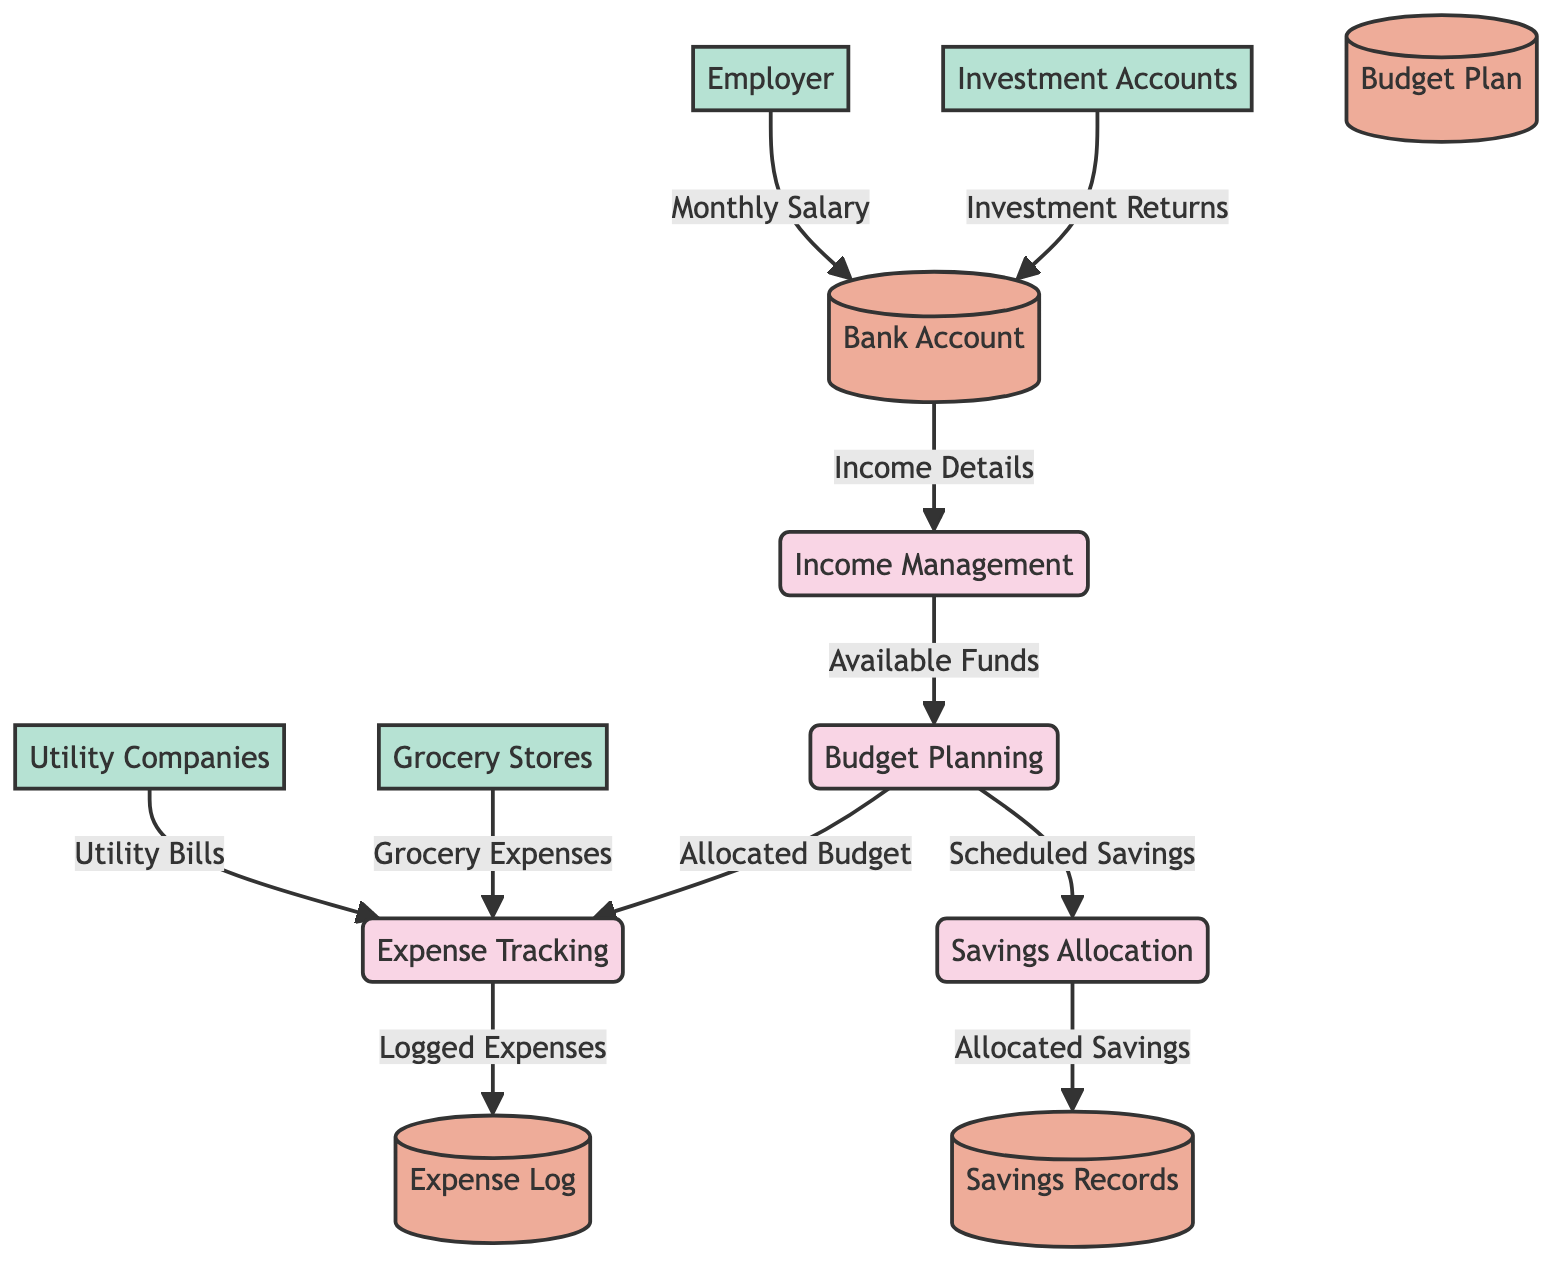What is the first process in the diagram? The first process listed in the diagram is "Income Management," which is labeled as P1.
Answer: Income Management How many data stores are included in the diagram? There are a total of four data stores, which are Bank Account, Expense Log, Budget Plan, and Savings Records.
Answer: Four What data flows from the Employer to the Bank Account? The data flow from the Employer to the Bank Account is the "Monthly Salary." This is indicated by the connection F1 between these two entities.
Answer: Monthly Salary Which process receives "Utility Bills" as input? The process that receives "Utility Bills" is "Expense Tracking," which is connected to the Utility Companies through data flow F7.
Answer: Expense Tracking What is the final output of the Savings Allocation process? The final output of the Savings Allocation process is "Allocated Savings," which is sent to the Savings Records data store indicated by flow F10.
Answer: Allocated Savings What is the relationship between Budget Planning and Savings Allocation? The relationship is that Budget Planning sends "Scheduled Savings" to Savings Allocation, which indicates that the budgeted amounts are being allocated towards savings. This is represented by the flow F9 in the diagram.
Answer: Scheduled Savings Which external entity provides additional income sources? The external entity that provides additional income sources is "Investment Accounts." This is indicated in the diagram with the data flow from Investment Accounts to the Bank Account as "Investment Returns."
Answer: Investment Accounts What type of information is stored in the Expense Log? The Expense Log stores "Detailed records of all household expenses," which captures the logged expenses tracked during the expense tracking process.
Answer: Detailed records of all household expenses Which process establishes the monthly budget? The process that establishes the monthly budget is "Budget Planning," which receives input from Income Management regarding available funds.
Answer: Budget Planning 